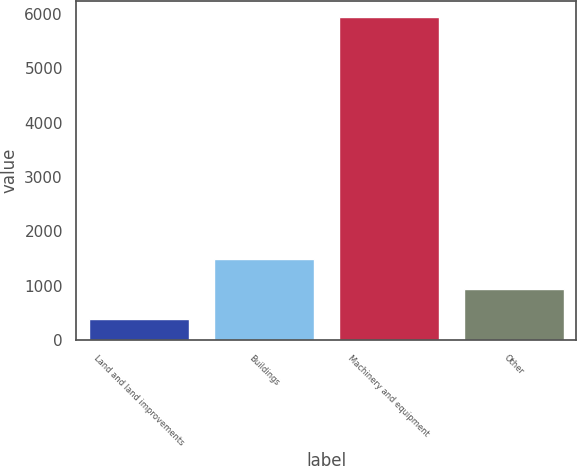<chart> <loc_0><loc_0><loc_500><loc_500><bar_chart><fcel>Land and land improvements<fcel>Buildings<fcel>Machinery and equipment<fcel>Other<nl><fcel>385<fcel>1496.2<fcel>5941<fcel>940.6<nl></chart> 